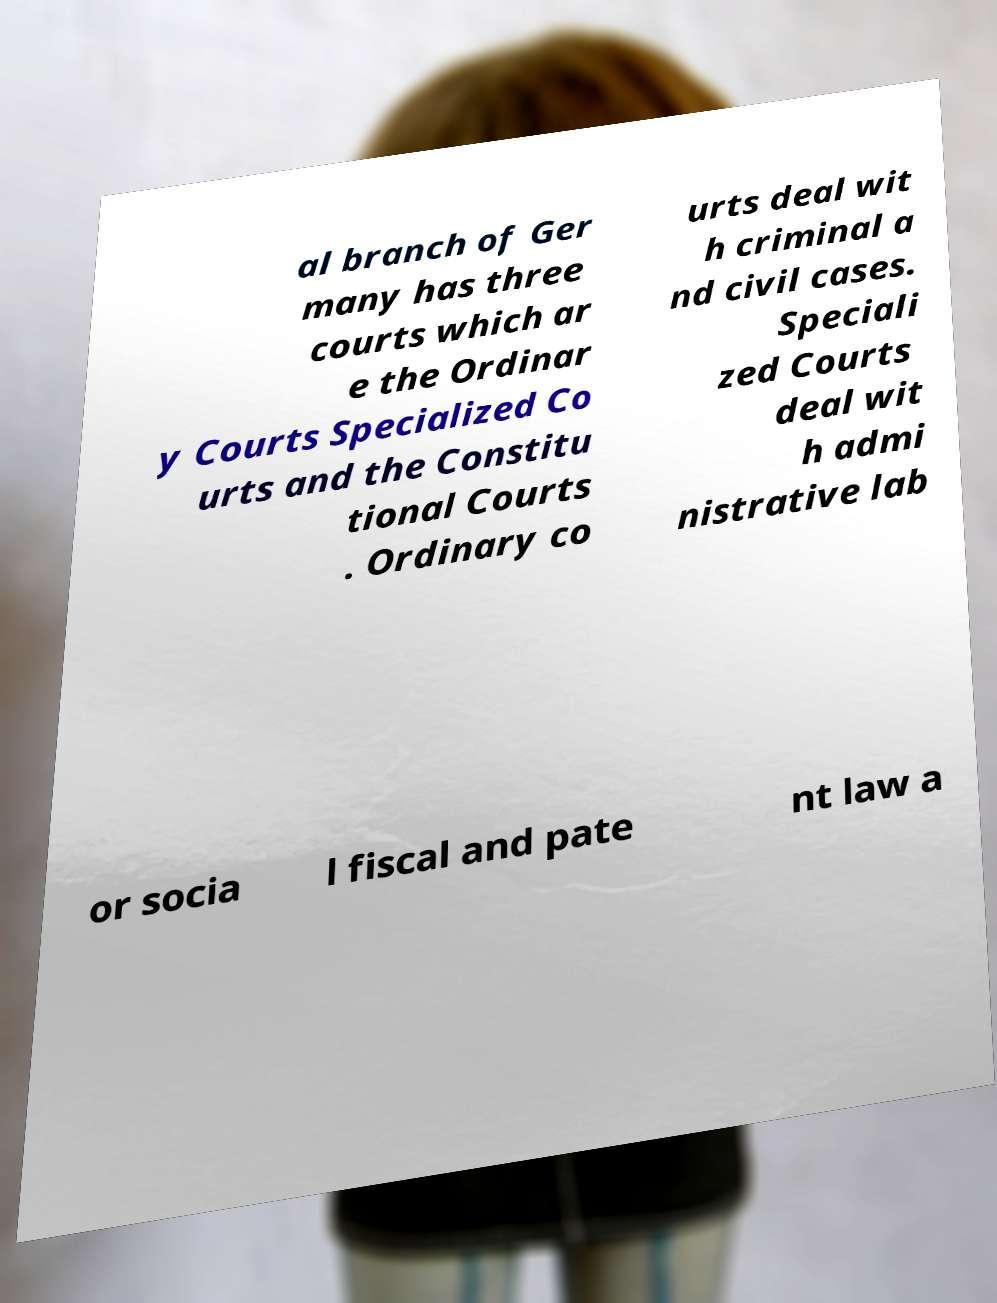Could you extract and type out the text from this image? al branch of Ger many has three courts which ar e the Ordinar y Courts Specialized Co urts and the Constitu tional Courts . Ordinary co urts deal wit h criminal a nd civil cases. Speciali zed Courts deal wit h admi nistrative lab or socia l fiscal and pate nt law a 